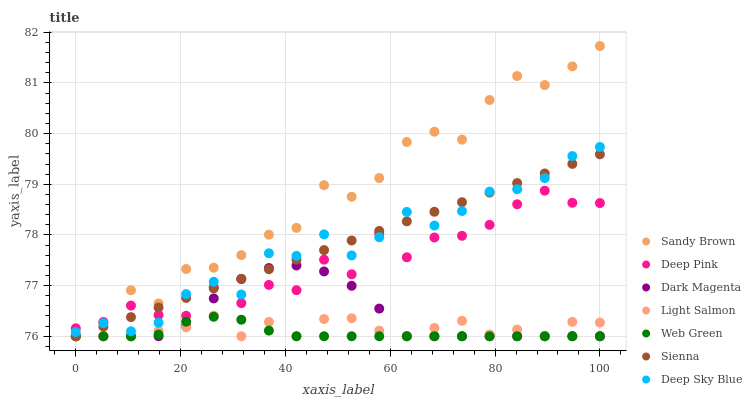Does Web Green have the minimum area under the curve?
Answer yes or no. Yes. Does Sandy Brown have the maximum area under the curve?
Answer yes or no. Yes. Does Deep Pink have the minimum area under the curve?
Answer yes or no. No. Does Deep Pink have the maximum area under the curve?
Answer yes or no. No. Is Sienna the smoothest?
Answer yes or no. Yes. Is Deep Pink the roughest?
Answer yes or no. Yes. Is Dark Magenta the smoothest?
Answer yes or no. No. Is Dark Magenta the roughest?
Answer yes or no. No. Does Light Salmon have the lowest value?
Answer yes or no. Yes. Does Deep Pink have the lowest value?
Answer yes or no. No. Does Sandy Brown have the highest value?
Answer yes or no. Yes. Does Deep Pink have the highest value?
Answer yes or no. No. Is Web Green less than Deep Pink?
Answer yes or no. Yes. Is Deep Pink greater than Light Salmon?
Answer yes or no. Yes. Does Sandy Brown intersect Deep Pink?
Answer yes or no. Yes. Is Sandy Brown less than Deep Pink?
Answer yes or no. No. Is Sandy Brown greater than Deep Pink?
Answer yes or no. No. Does Web Green intersect Deep Pink?
Answer yes or no. No. 